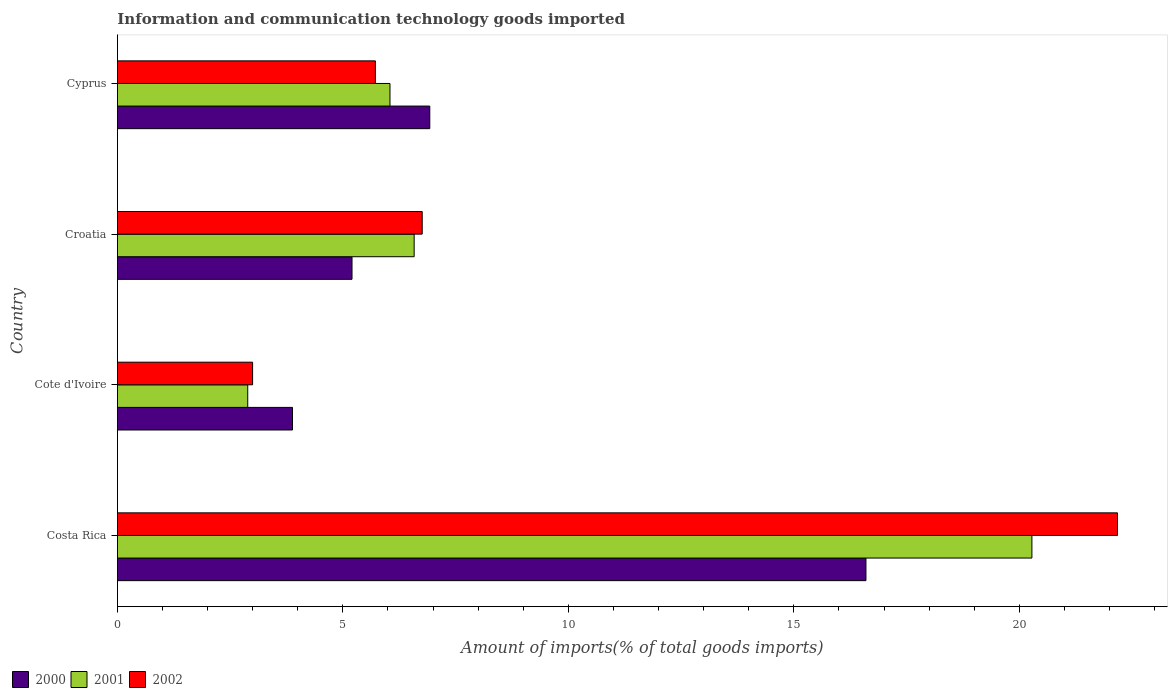Are the number of bars on each tick of the Y-axis equal?
Give a very brief answer. Yes. How many bars are there on the 2nd tick from the top?
Provide a succinct answer. 3. How many bars are there on the 1st tick from the bottom?
Offer a terse response. 3. In how many cases, is the number of bars for a given country not equal to the number of legend labels?
Your response must be concise. 0. What is the amount of goods imported in 2002 in Cyprus?
Keep it short and to the point. 5.72. Across all countries, what is the maximum amount of goods imported in 2001?
Your answer should be compact. 20.28. Across all countries, what is the minimum amount of goods imported in 2000?
Give a very brief answer. 3.88. In which country was the amount of goods imported in 2001 minimum?
Ensure brevity in your answer.  Cote d'Ivoire. What is the total amount of goods imported in 2002 in the graph?
Offer a terse response. 37.65. What is the difference between the amount of goods imported in 2002 in Cote d'Ivoire and that in Croatia?
Your response must be concise. -3.76. What is the difference between the amount of goods imported in 2002 in Croatia and the amount of goods imported in 2000 in Cote d'Ivoire?
Keep it short and to the point. 2.88. What is the average amount of goods imported in 2000 per country?
Provide a short and direct response. 8.15. What is the difference between the amount of goods imported in 2000 and amount of goods imported in 2001 in Costa Rica?
Provide a succinct answer. -3.68. What is the ratio of the amount of goods imported in 2002 in Costa Rica to that in Croatia?
Offer a terse response. 3.28. Is the amount of goods imported in 2002 in Cote d'Ivoire less than that in Croatia?
Ensure brevity in your answer.  Yes. Is the difference between the amount of goods imported in 2000 in Cote d'Ivoire and Croatia greater than the difference between the amount of goods imported in 2001 in Cote d'Ivoire and Croatia?
Your answer should be compact. Yes. What is the difference between the highest and the second highest amount of goods imported in 2002?
Provide a short and direct response. 15.42. What is the difference between the highest and the lowest amount of goods imported in 2001?
Keep it short and to the point. 17.39. In how many countries, is the amount of goods imported in 2001 greater than the average amount of goods imported in 2001 taken over all countries?
Give a very brief answer. 1. How many bars are there?
Your response must be concise. 12. Are all the bars in the graph horizontal?
Your answer should be very brief. Yes. What is the difference between two consecutive major ticks on the X-axis?
Your answer should be very brief. 5. Are the values on the major ticks of X-axis written in scientific E-notation?
Keep it short and to the point. No. Does the graph contain any zero values?
Make the answer very short. No. How many legend labels are there?
Offer a very short reply. 3. What is the title of the graph?
Your answer should be compact. Information and communication technology goods imported. Does "1974" appear as one of the legend labels in the graph?
Offer a terse response. No. What is the label or title of the X-axis?
Offer a terse response. Amount of imports(% of total goods imports). What is the label or title of the Y-axis?
Offer a terse response. Country. What is the Amount of imports(% of total goods imports) in 2000 in Costa Rica?
Provide a succinct answer. 16.6. What is the Amount of imports(% of total goods imports) in 2001 in Costa Rica?
Keep it short and to the point. 20.28. What is the Amount of imports(% of total goods imports) in 2002 in Costa Rica?
Your response must be concise. 22.18. What is the Amount of imports(% of total goods imports) of 2000 in Cote d'Ivoire?
Make the answer very short. 3.88. What is the Amount of imports(% of total goods imports) of 2001 in Cote d'Ivoire?
Your response must be concise. 2.89. What is the Amount of imports(% of total goods imports) in 2002 in Cote d'Ivoire?
Give a very brief answer. 3. What is the Amount of imports(% of total goods imports) of 2000 in Croatia?
Your answer should be very brief. 5.2. What is the Amount of imports(% of total goods imports) in 2001 in Croatia?
Keep it short and to the point. 6.58. What is the Amount of imports(% of total goods imports) in 2002 in Croatia?
Offer a terse response. 6.76. What is the Amount of imports(% of total goods imports) in 2000 in Cyprus?
Give a very brief answer. 6.93. What is the Amount of imports(% of total goods imports) of 2001 in Cyprus?
Provide a succinct answer. 6.04. What is the Amount of imports(% of total goods imports) of 2002 in Cyprus?
Your answer should be compact. 5.72. Across all countries, what is the maximum Amount of imports(% of total goods imports) in 2000?
Offer a terse response. 16.6. Across all countries, what is the maximum Amount of imports(% of total goods imports) of 2001?
Ensure brevity in your answer.  20.28. Across all countries, what is the maximum Amount of imports(% of total goods imports) of 2002?
Offer a terse response. 22.18. Across all countries, what is the minimum Amount of imports(% of total goods imports) in 2000?
Provide a succinct answer. 3.88. Across all countries, what is the minimum Amount of imports(% of total goods imports) of 2001?
Make the answer very short. 2.89. Across all countries, what is the minimum Amount of imports(% of total goods imports) of 2002?
Your answer should be very brief. 3. What is the total Amount of imports(% of total goods imports) in 2000 in the graph?
Make the answer very short. 32.61. What is the total Amount of imports(% of total goods imports) of 2001 in the graph?
Ensure brevity in your answer.  35.79. What is the total Amount of imports(% of total goods imports) of 2002 in the graph?
Provide a succinct answer. 37.65. What is the difference between the Amount of imports(% of total goods imports) of 2000 in Costa Rica and that in Cote d'Ivoire?
Offer a very short reply. 12.72. What is the difference between the Amount of imports(% of total goods imports) in 2001 in Costa Rica and that in Cote d'Ivoire?
Your answer should be very brief. 17.39. What is the difference between the Amount of imports(% of total goods imports) of 2002 in Costa Rica and that in Cote d'Ivoire?
Offer a very short reply. 19.18. What is the difference between the Amount of imports(% of total goods imports) of 2000 in Costa Rica and that in Croatia?
Make the answer very short. 11.4. What is the difference between the Amount of imports(% of total goods imports) of 2001 in Costa Rica and that in Croatia?
Offer a very short reply. 13.7. What is the difference between the Amount of imports(% of total goods imports) of 2002 in Costa Rica and that in Croatia?
Keep it short and to the point. 15.42. What is the difference between the Amount of imports(% of total goods imports) of 2000 in Costa Rica and that in Cyprus?
Ensure brevity in your answer.  9.67. What is the difference between the Amount of imports(% of total goods imports) in 2001 in Costa Rica and that in Cyprus?
Offer a very short reply. 14.23. What is the difference between the Amount of imports(% of total goods imports) of 2002 in Costa Rica and that in Cyprus?
Offer a terse response. 16.46. What is the difference between the Amount of imports(% of total goods imports) of 2000 in Cote d'Ivoire and that in Croatia?
Your answer should be very brief. -1.32. What is the difference between the Amount of imports(% of total goods imports) of 2001 in Cote d'Ivoire and that in Croatia?
Your response must be concise. -3.69. What is the difference between the Amount of imports(% of total goods imports) in 2002 in Cote d'Ivoire and that in Croatia?
Your answer should be compact. -3.76. What is the difference between the Amount of imports(% of total goods imports) of 2000 in Cote d'Ivoire and that in Cyprus?
Your answer should be compact. -3.04. What is the difference between the Amount of imports(% of total goods imports) in 2001 in Cote d'Ivoire and that in Cyprus?
Your answer should be very brief. -3.15. What is the difference between the Amount of imports(% of total goods imports) in 2002 in Cote d'Ivoire and that in Cyprus?
Your response must be concise. -2.72. What is the difference between the Amount of imports(% of total goods imports) of 2000 in Croatia and that in Cyprus?
Provide a succinct answer. -1.72. What is the difference between the Amount of imports(% of total goods imports) of 2001 in Croatia and that in Cyprus?
Your response must be concise. 0.54. What is the difference between the Amount of imports(% of total goods imports) of 2002 in Croatia and that in Cyprus?
Offer a terse response. 1.04. What is the difference between the Amount of imports(% of total goods imports) of 2000 in Costa Rica and the Amount of imports(% of total goods imports) of 2001 in Cote d'Ivoire?
Provide a succinct answer. 13.71. What is the difference between the Amount of imports(% of total goods imports) in 2000 in Costa Rica and the Amount of imports(% of total goods imports) in 2002 in Cote d'Ivoire?
Make the answer very short. 13.6. What is the difference between the Amount of imports(% of total goods imports) in 2001 in Costa Rica and the Amount of imports(% of total goods imports) in 2002 in Cote d'Ivoire?
Make the answer very short. 17.28. What is the difference between the Amount of imports(% of total goods imports) of 2000 in Costa Rica and the Amount of imports(% of total goods imports) of 2001 in Croatia?
Provide a succinct answer. 10.02. What is the difference between the Amount of imports(% of total goods imports) of 2000 in Costa Rica and the Amount of imports(% of total goods imports) of 2002 in Croatia?
Ensure brevity in your answer.  9.84. What is the difference between the Amount of imports(% of total goods imports) of 2001 in Costa Rica and the Amount of imports(% of total goods imports) of 2002 in Croatia?
Your answer should be compact. 13.52. What is the difference between the Amount of imports(% of total goods imports) in 2000 in Costa Rica and the Amount of imports(% of total goods imports) in 2001 in Cyprus?
Make the answer very short. 10.55. What is the difference between the Amount of imports(% of total goods imports) of 2000 in Costa Rica and the Amount of imports(% of total goods imports) of 2002 in Cyprus?
Your response must be concise. 10.88. What is the difference between the Amount of imports(% of total goods imports) in 2001 in Costa Rica and the Amount of imports(% of total goods imports) in 2002 in Cyprus?
Offer a terse response. 14.56. What is the difference between the Amount of imports(% of total goods imports) in 2000 in Cote d'Ivoire and the Amount of imports(% of total goods imports) in 2001 in Croatia?
Offer a terse response. -2.7. What is the difference between the Amount of imports(% of total goods imports) in 2000 in Cote d'Ivoire and the Amount of imports(% of total goods imports) in 2002 in Croatia?
Your response must be concise. -2.88. What is the difference between the Amount of imports(% of total goods imports) in 2001 in Cote d'Ivoire and the Amount of imports(% of total goods imports) in 2002 in Croatia?
Make the answer very short. -3.87. What is the difference between the Amount of imports(% of total goods imports) of 2000 in Cote d'Ivoire and the Amount of imports(% of total goods imports) of 2001 in Cyprus?
Keep it short and to the point. -2.16. What is the difference between the Amount of imports(% of total goods imports) of 2000 in Cote d'Ivoire and the Amount of imports(% of total goods imports) of 2002 in Cyprus?
Your response must be concise. -1.84. What is the difference between the Amount of imports(% of total goods imports) in 2001 in Cote d'Ivoire and the Amount of imports(% of total goods imports) in 2002 in Cyprus?
Ensure brevity in your answer.  -2.83. What is the difference between the Amount of imports(% of total goods imports) of 2000 in Croatia and the Amount of imports(% of total goods imports) of 2001 in Cyprus?
Provide a short and direct response. -0.84. What is the difference between the Amount of imports(% of total goods imports) of 2000 in Croatia and the Amount of imports(% of total goods imports) of 2002 in Cyprus?
Provide a short and direct response. -0.52. What is the difference between the Amount of imports(% of total goods imports) in 2001 in Croatia and the Amount of imports(% of total goods imports) in 2002 in Cyprus?
Your answer should be compact. 0.86. What is the average Amount of imports(% of total goods imports) of 2000 per country?
Your answer should be compact. 8.15. What is the average Amount of imports(% of total goods imports) of 2001 per country?
Your answer should be very brief. 8.95. What is the average Amount of imports(% of total goods imports) of 2002 per country?
Provide a succinct answer. 9.41. What is the difference between the Amount of imports(% of total goods imports) of 2000 and Amount of imports(% of total goods imports) of 2001 in Costa Rica?
Your answer should be compact. -3.68. What is the difference between the Amount of imports(% of total goods imports) of 2000 and Amount of imports(% of total goods imports) of 2002 in Costa Rica?
Keep it short and to the point. -5.58. What is the difference between the Amount of imports(% of total goods imports) of 2001 and Amount of imports(% of total goods imports) of 2002 in Costa Rica?
Give a very brief answer. -1.9. What is the difference between the Amount of imports(% of total goods imports) in 2000 and Amount of imports(% of total goods imports) in 2001 in Cote d'Ivoire?
Ensure brevity in your answer.  0.99. What is the difference between the Amount of imports(% of total goods imports) of 2000 and Amount of imports(% of total goods imports) of 2002 in Cote d'Ivoire?
Give a very brief answer. 0.89. What is the difference between the Amount of imports(% of total goods imports) of 2001 and Amount of imports(% of total goods imports) of 2002 in Cote d'Ivoire?
Offer a terse response. -0.11. What is the difference between the Amount of imports(% of total goods imports) in 2000 and Amount of imports(% of total goods imports) in 2001 in Croatia?
Keep it short and to the point. -1.38. What is the difference between the Amount of imports(% of total goods imports) of 2000 and Amount of imports(% of total goods imports) of 2002 in Croatia?
Keep it short and to the point. -1.56. What is the difference between the Amount of imports(% of total goods imports) in 2001 and Amount of imports(% of total goods imports) in 2002 in Croatia?
Give a very brief answer. -0.18. What is the difference between the Amount of imports(% of total goods imports) in 2000 and Amount of imports(% of total goods imports) in 2001 in Cyprus?
Ensure brevity in your answer.  0.88. What is the difference between the Amount of imports(% of total goods imports) of 2000 and Amount of imports(% of total goods imports) of 2002 in Cyprus?
Ensure brevity in your answer.  1.21. What is the difference between the Amount of imports(% of total goods imports) in 2001 and Amount of imports(% of total goods imports) in 2002 in Cyprus?
Offer a very short reply. 0.32. What is the ratio of the Amount of imports(% of total goods imports) of 2000 in Costa Rica to that in Cote d'Ivoire?
Your answer should be very brief. 4.27. What is the ratio of the Amount of imports(% of total goods imports) of 2001 in Costa Rica to that in Cote d'Ivoire?
Ensure brevity in your answer.  7.02. What is the ratio of the Amount of imports(% of total goods imports) in 2002 in Costa Rica to that in Cote d'Ivoire?
Offer a terse response. 7.4. What is the ratio of the Amount of imports(% of total goods imports) of 2000 in Costa Rica to that in Croatia?
Your answer should be very brief. 3.19. What is the ratio of the Amount of imports(% of total goods imports) in 2001 in Costa Rica to that in Croatia?
Offer a very short reply. 3.08. What is the ratio of the Amount of imports(% of total goods imports) of 2002 in Costa Rica to that in Croatia?
Provide a short and direct response. 3.28. What is the ratio of the Amount of imports(% of total goods imports) of 2000 in Costa Rica to that in Cyprus?
Provide a short and direct response. 2.4. What is the ratio of the Amount of imports(% of total goods imports) in 2001 in Costa Rica to that in Cyprus?
Keep it short and to the point. 3.35. What is the ratio of the Amount of imports(% of total goods imports) of 2002 in Costa Rica to that in Cyprus?
Your answer should be compact. 3.88. What is the ratio of the Amount of imports(% of total goods imports) in 2000 in Cote d'Ivoire to that in Croatia?
Offer a terse response. 0.75. What is the ratio of the Amount of imports(% of total goods imports) in 2001 in Cote d'Ivoire to that in Croatia?
Offer a terse response. 0.44. What is the ratio of the Amount of imports(% of total goods imports) of 2002 in Cote d'Ivoire to that in Croatia?
Your answer should be compact. 0.44. What is the ratio of the Amount of imports(% of total goods imports) of 2000 in Cote d'Ivoire to that in Cyprus?
Give a very brief answer. 0.56. What is the ratio of the Amount of imports(% of total goods imports) of 2001 in Cote d'Ivoire to that in Cyprus?
Make the answer very short. 0.48. What is the ratio of the Amount of imports(% of total goods imports) of 2002 in Cote d'Ivoire to that in Cyprus?
Ensure brevity in your answer.  0.52. What is the ratio of the Amount of imports(% of total goods imports) in 2000 in Croatia to that in Cyprus?
Your answer should be compact. 0.75. What is the ratio of the Amount of imports(% of total goods imports) of 2001 in Croatia to that in Cyprus?
Provide a succinct answer. 1.09. What is the ratio of the Amount of imports(% of total goods imports) in 2002 in Croatia to that in Cyprus?
Offer a terse response. 1.18. What is the difference between the highest and the second highest Amount of imports(% of total goods imports) in 2000?
Your answer should be compact. 9.67. What is the difference between the highest and the second highest Amount of imports(% of total goods imports) in 2001?
Ensure brevity in your answer.  13.7. What is the difference between the highest and the second highest Amount of imports(% of total goods imports) in 2002?
Provide a succinct answer. 15.42. What is the difference between the highest and the lowest Amount of imports(% of total goods imports) in 2000?
Make the answer very short. 12.72. What is the difference between the highest and the lowest Amount of imports(% of total goods imports) in 2001?
Give a very brief answer. 17.39. What is the difference between the highest and the lowest Amount of imports(% of total goods imports) of 2002?
Provide a short and direct response. 19.18. 